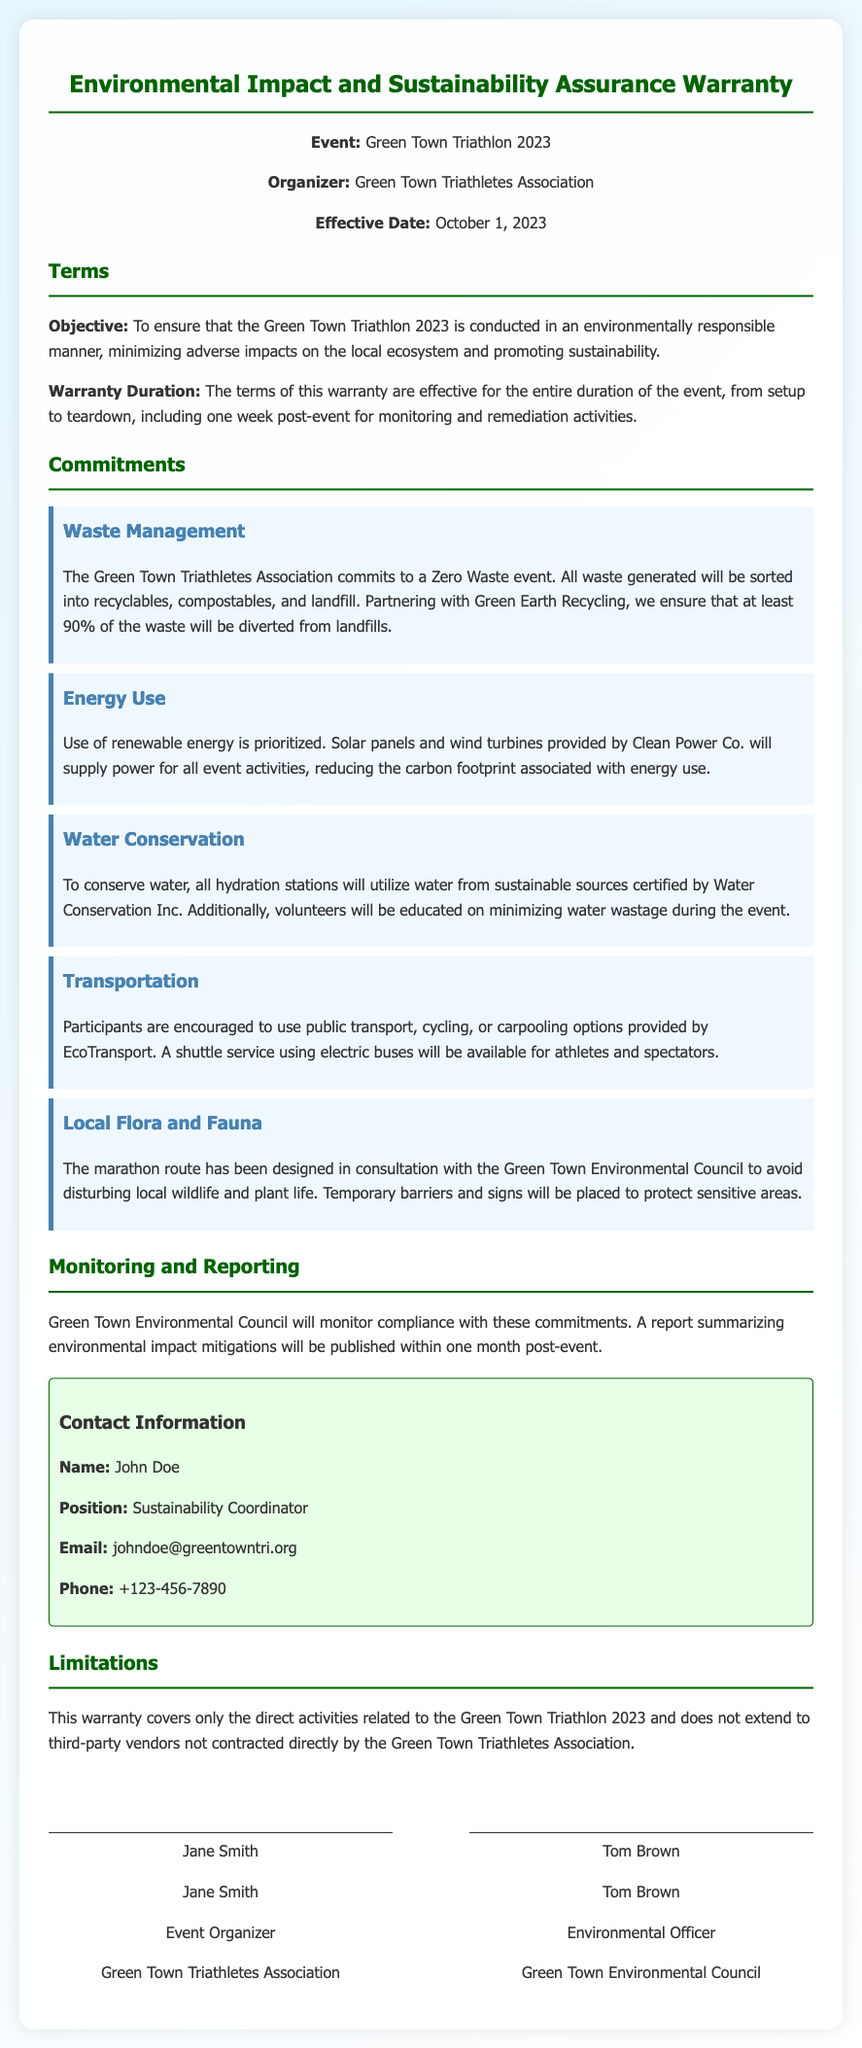What is the event title? The event title is stated in the header section of the document, which identifies the specific triathlon.
Answer: Green Town Triathlon 2023 Who is the organizer? The organizer is mentioned in the header info section, indicating the group responsible for the event.
Answer: Green Town Triathletes Association What is the warranty duration? The warranty duration specifies the time period during which the commitments of the warranty are effective.
Answer: Entire duration of the event, from setup to teardown, including one week post-event What commitment is made regarding energy use? This commitment details the source of energy for the event, highlighting the sustainability effort.
Answer: Use of renewable energy How will waste be managed at the event? The waste management commitment explains the plan for sorting and disposing of waste in an eco-friendly manner.
Answer: Zero Waste event What is the effective date of the warranty? The effective date indicates when the warranty starts and is included in the header information.
Answer: October 1, 2023 Who will monitor compliance with the commitments? The document specifies the organization responsible for overseeing the environmental impact commitments.
Answer: Green Town Environmental Council What type of report will be published post-event? The report mentioned in the document summarizes the environmental impact mitigations and who will publish it.
Answer: A report summarizing environmental impact mitigations What is a limitation of the warranty? The limitations section outlines restrictions regarding which activities and vendors are covered by the warranty.
Answer: Direct activities related to the Green Town Triathlon 2023 